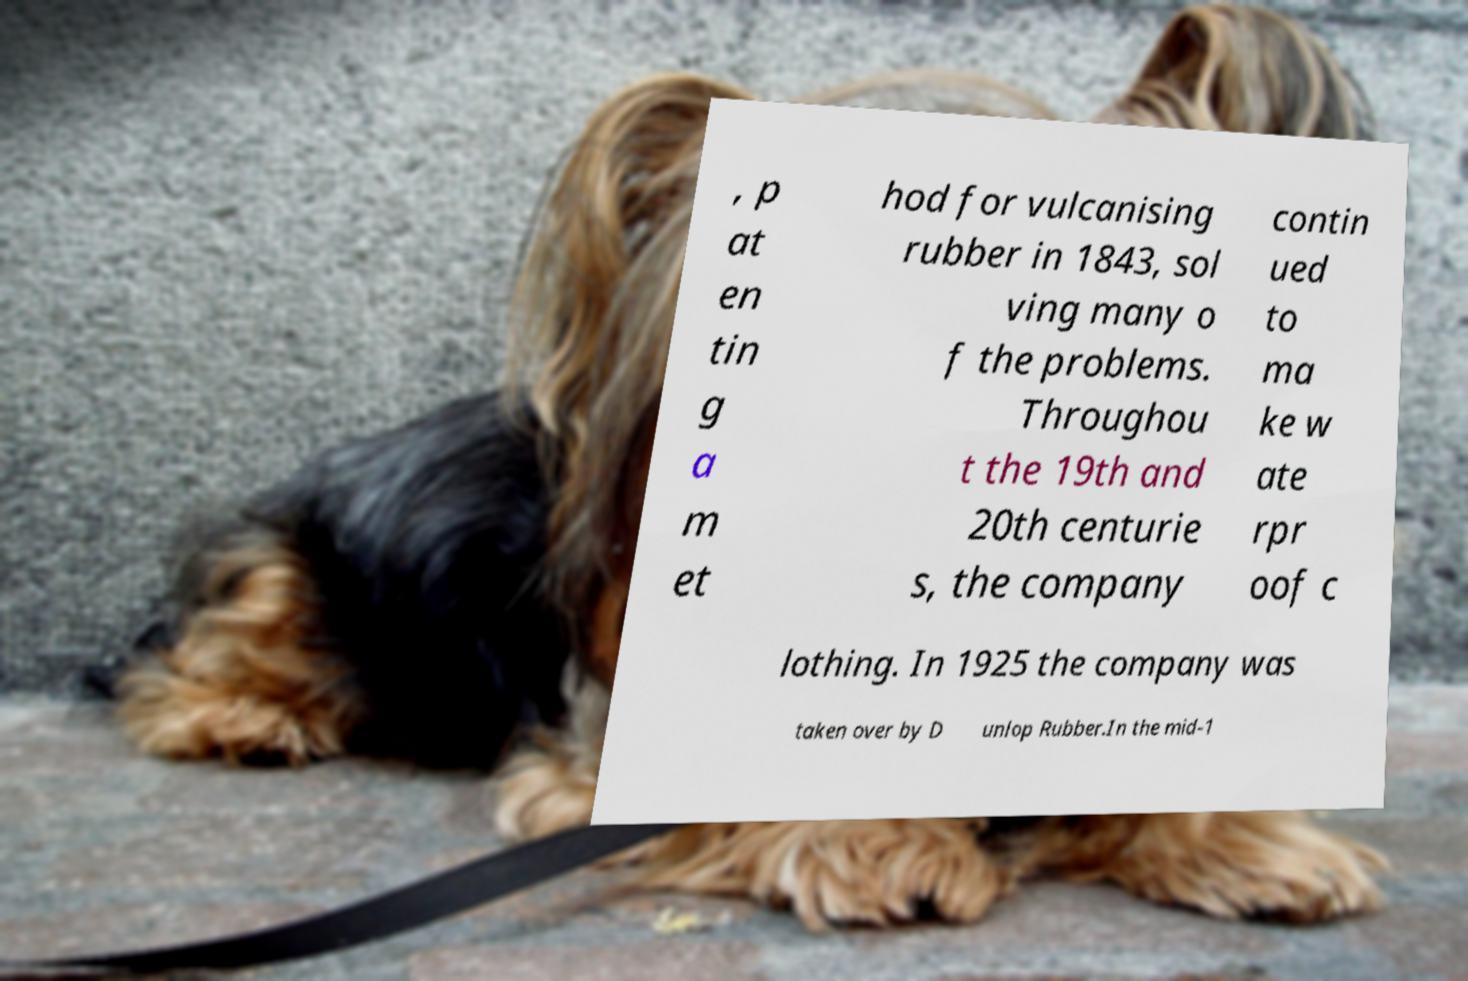Please read and relay the text visible in this image. What does it say? , p at en tin g a m et hod for vulcanising rubber in 1843, sol ving many o f the problems. Throughou t the 19th and 20th centurie s, the company contin ued to ma ke w ate rpr oof c lothing. In 1925 the company was taken over by D unlop Rubber.In the mid-1 